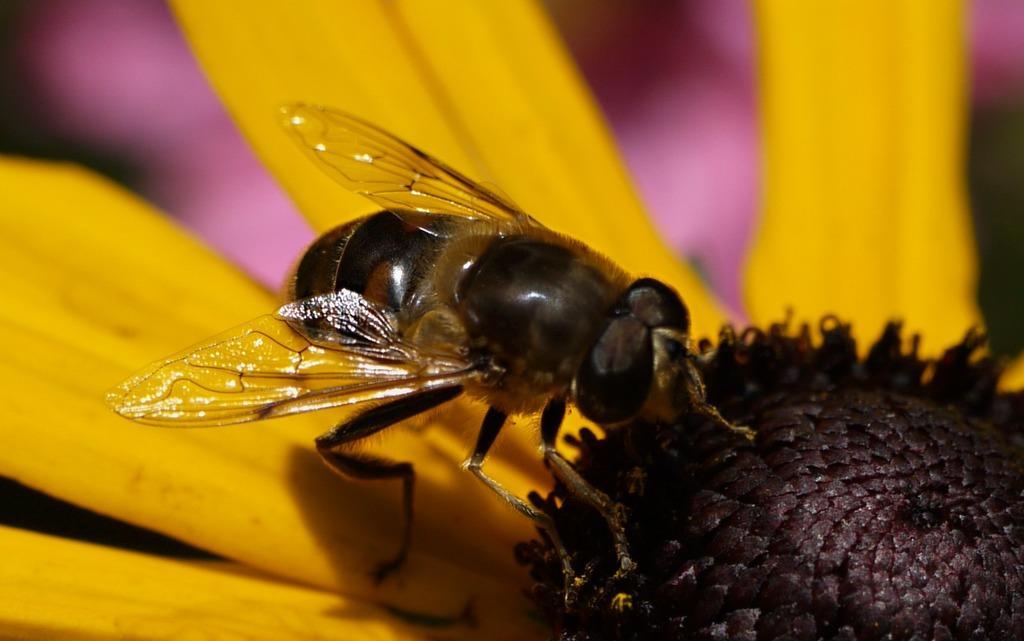In one or two sentences, can you explain what this image depicts? In this image I can see a bee on a flower. The petals of a flower are in yellow color. The background is blurred. 